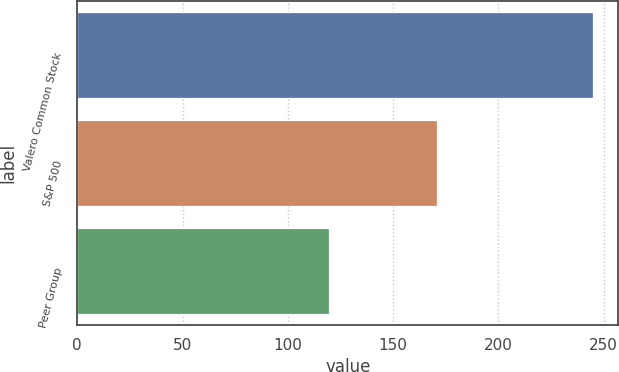Convert chart. <chart><loc_0><loc_0><loc_500><loc_500><bar_chart><fcel>Valero Common Stock<fcel>S&P 500<fcel>Peer Group<nl><fcel>244.71<fcel>170.84<fcel>119.45<nl></chart> 